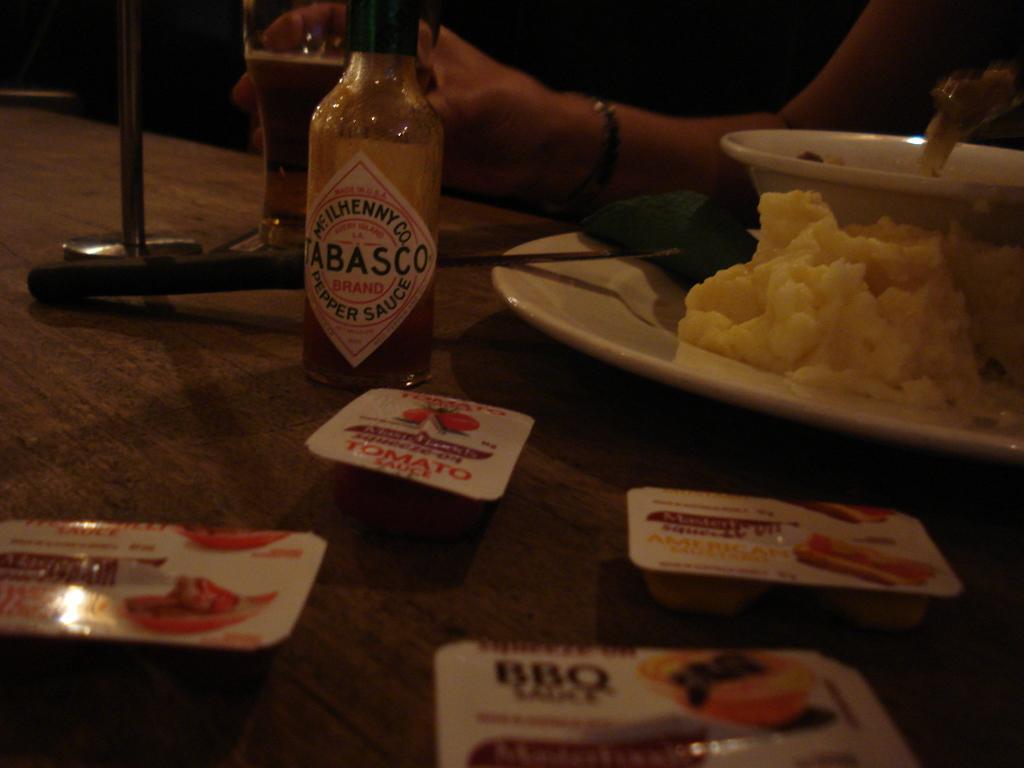In one or two sentences, can you explain what this image depicts? In this image In the middle there is a table on that there is a bottle, glass, plate, bowl and some food items, In front of the table there is a woman she is holding a glass. 